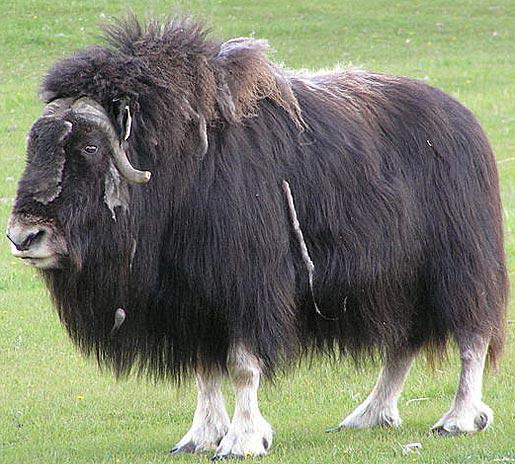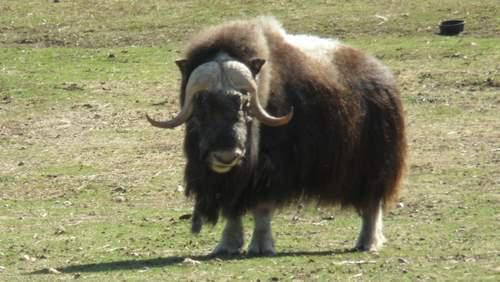The first image is the image on the left, the second image is the image on the right. Examine the images to the left and right. Is the description "There are trees in the background of the image on the left." accurate? Answer yes or no. No. 